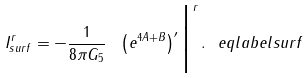<formula> <loc_0><loc_0><loc_500><loc_500>I ^ { r } _ { s u r f } = - \frac { 1 } { 8 \pi G _ { 5 } } \ \left ( e ^ { 4 A + B } \right ) ^ { \prime } \Big | ^ { r } \, . \ e q l a b e l { s u r f }</formula> 